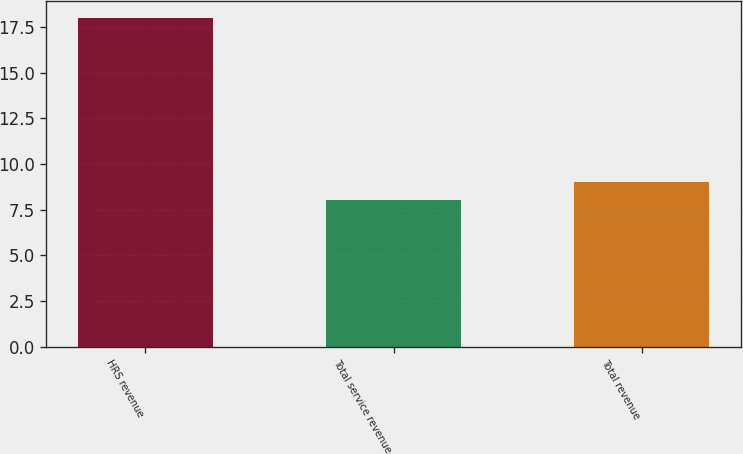Convert chart. <chart><loc_0><loc_0><loc_500><loc_500><bar_chart><fcel>HRS revenue<fcel>Total service revenue<fcel>Total revenue<nl><fcel>18<fcel>8<fcel>9<nl></chart> 